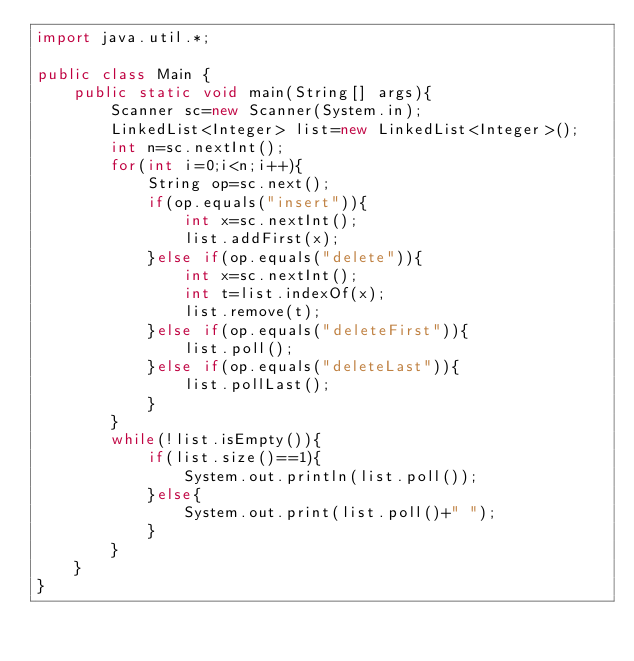Convert code to text. <code><loc_0><loc_0><loc_500><loc_500><_Java_>import java.util.*;

public class Main {
	public static void main(String[] args){
		Scanner sc=new Scanner(System.in);
		LinkedList<Integer> list=new LinkedList<Integer>();
		int n=sc.nextInt();
		for(int i=0;i<n;i++){
			String op=sc.next();
			if(op.equals("insert")){
				int x=sc.nextInt();
				list.addFirst(x);
			}else if(op.equals("delete")){
				int x=sc.nextInt();
				int t=list.indexOf(x);
				list.remove(t);
			}else if(op.equals("deleteFirst")){
				list.poll();
			}else if(op.equals("deleteLast")){
				list.pollLast();
			}
		}
		while(!list.isEmpty()){
			if(list.size()==1){
				System.out.println(list.poll());
			}else{
				System.out.print(list.poll()+" ");
			}
		}
	}
}</code> 